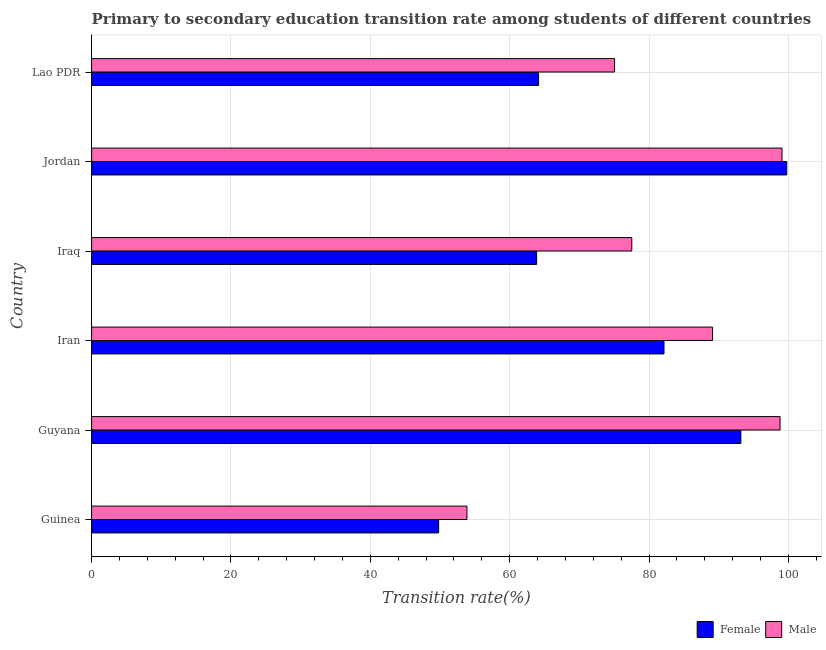How many different coloured bars are there?
Offer a terse response. 2. How many groups of bars are there?
Offer a very short reply. 6. Are the number of bars on each tick of the Y-axis equal?
Keep it short and to the point. Yes. How many bars are there on the 1st tick from the top?
Keep it short and to the point. 2. How many bars are there on the 5th tick from the bottom?
Offer a terse response. 2. What is the label of the 5th group of bars from the top?
Offer a very short reply. Guyana. What is the transition rate among female students in Guyana?
Keep it short and to the point. 93.18. Across all countries, what is the maximum transition rate among male students?
Make the answer very short. 99.08. Across all countries, what is the minimum transition rate among female students?
Provide a short and direct response. 49.81. In which country was the transition rate among female students maximum?
Your answer should be very brief. Jordan. In which country was the transition rate among male students minimum?
Offer a very short reply. Guinea. What is the total transition rate among female students in the graph?
Give a very brief answer. 452.93. What is the difference between the transition rate among male students in Guinea and that in Jordan?
Offer a very short reply. -45.22. What is the difference between the transition rate among male students in Guinea and the transition rate among female students in Lao PDR?
Ensure brevity in your answer.  -10.28. What is the average transition rate among male students per country?
Give a very brief answer. 82.25. What is the difference between the transition rate among male students and transition rate among female students in Lao PDR?
Offer a terse response. 10.91. What is the ratio of the transition rate among male students in Iran to that in Lao PDR?
Keep it short and to the point. 1.19. Is the difference between the transition rate among female students in Jordan and Lao PDR greater than the difference between the transition rate among male students in Jordan and Lao PDR?
Your answer should be compact. Yes. What is the difference between the highest and the second highest transition rate among female students?
Offer a terse response. 6.58. What is the difference between the highest and the lowest transition rate among male students?
Offer a very short reply. 45.22. Is the sum of the transition rate among male students in Guinea and Iran greater than the maximum transition rate among female students across all countries?
Offer a terse response. Yes. What does the 2nd bar from the top in Guyana represents?
Provide a short and direct response. Female. What does the 1st bar from the bottom in Iraq represents?
Give a very brief answer. Female. How many bars are there?
Your response must be concise. 12. Are all the bars in the graph horizontal?
Your answer should be compact. Yes. How many countries are there in the graph?
Offer a terse response. 6. What is the difference between two consecutive major ticks on the X-axis?
Give a very brief answer. 20. Are the values on the major ticks of X-axis written in scientific E-notation?
Offer a very short reply. No. Does the graph contain grids?
Your answer should be compact. Yes. Where does the legend appear in the graph?
Offer a terse response. Bottom right. How many legend labels are there?
Provide a short and direct response. 2. How are the legend labels stacked?
Keep it short and to the point. Horizontal. What is the title of the graph?
Offer a very short reply. Primary to secondary education transition rate among students of different countries. Does "Services" appear as one of the legend labels in the graph?
Offer a terse response. No. What is the label or title of the X-axis?
Keep it short and to the point. Transition rate(%). What is the Transition rate(%) of Female in Guinea?
Ensure brevity in your answer.  49.81. What is the Transition rate(%) of Male in Guinea?
Your response must be concise. 53.87. What is the Transition rate(%) in Female in Guyana?
Offer a very short reply. 93.18. What is the Transition rate(%) of Male in Guyana?
Keep it short and to the point. 98.81. What is the Transition rate(%) in Female in Iran?
Provide a short and direct response. 82.15. What is the Transition rate(%) of Male in Iran?
Your response must be concise. 89.12. What is the Transition rate(%) of Female in Iraq?
Ensure brevity in your answer.  63.87. What is the Transition rate(%) in Male in Iraq?
Offer a terse response. 77.53. What is the Transition rate(%) of Female in Jordan?
Make the answer very short. 99.77. What is the Transition rate(%) of Male in Jordan?
Offer a terse response. 99.08. What is the Transition rate(%) in Female in Lao PDR?
Ensure brevity in your answer.  64.15. What is the Transition rate(%) in Male in Lao PDR?
Provide a short and direct response. 75.06. Across all countries, what is the maximum Transition rate(%) in Female?
Your answer should be compact. 99.77. Across all countries, what is the maximum Transition rate(%) in Male?
Offer a very short reply. 99.08. Across all countries, what is the minimum Transition rate(%) in Female?
Provide a succinct answer. 49.81. Across all countries, what is the minimum Transition rate(%) in Male?
Provide a short and direct response. 53.87. What is the total Transition rate(%) in Female in the graph?
Offer a terse response. 452.93. What is the total Transition rate(%) in Male in the graph?
Offer a very short reply. 493.47. What is the difference between the Transition rate(%) of Female in Guinea and that in Guyana?
Your answer should be compact. -43.37. What is the difference between the Transition rate(%) of Male in Guinea and that in Guyana?
Offer a terse response. -44.94. What is the difference between the Transition rate(%) of Female in Guinea and that in Iran?
Offer a terse response. -32.34. What is the difference between the Transition rate(%) of Male in Guinea and that in Iran?
Give a very brief answer. -35.26. What is the difference between the Transition rate(%) in Female in Guinea and that in Iraq?
Your answer should be compact. -14.06. What is the difference between the Transition rate(%) in Male in Guinea and that in Iraq?
Your answer should be compact. -23.66. What is the difference between the Transition rate(%) of Female in Guinea and that in Jordan?
Provide a succinct answer. -49.96. What is the difference between the Transition rate(%) of Male in Guinea and that in Jordan?
Ensure brevity in your answer.  -45.22. What is the difference between the Transition rate(%) in Female in Guinea and that in Lao PDR?
Make the answer very short. -14.34. What is the difference between the Transition rate(%) in Male in Guinea and that in Lao PDR?
Offer a very short reply. -21.19. What is the difference between the Transition rate(%) in Female in Guyana and that in Iran?
Provide a short and direct response. 11.03. What is the difference between the Transition rate(%) in Male in Guyana and that in Iran?
Ensure brevity in your answer.  9.69. What is the difference between the Transition rate(%) in Female in Guyana and that in Iraq?
Your answer should be very brief. 29.31. What is the difference between the Transition rate(%) in Male in Guyana and that in Iraq?
Ensure brevity in your answer.  21.28. What is the difference between the Transition rate(%) of Female in Guyana and that in Jordan?
Your answer should be very brief. -6.58. What is the difference between the Transition rate(%) in Male in Guyana and that in Jordan?
Give a very brief answer. -0.28. What is the difference between the Transition rate(%) of Female in Guyana and that in Lao PDR?
Offer a terse response. 29.03. What is the difference between the Transition rate(%) of Male in Guyana and that in Lao PDR?
Your response must be concise. 23.75. What is the difference between the Transition rate(%) in Female in Iran and that in Iraq?
Provide a short and direct response. 18.28. What is the difference between the Transition rate(%) of Male in Iran and that in Iraq?
Offer a very short reply. 11.59. What is the difference between the Transition rate(%) in Female in Iran and that in Jordan?
Provide a succinct answer. -17.62. What is the difference between the Transition rate(%) in Male in Iran and that in Jordan?
Provide a short and direct response. -9.96. What is the difference between the Transition rate(%) in Female in Iran and that in Lao PDR?
Make the answer very short. 18. What is the difference between the Transition rate(%) in Male in Iran and that in Lao PDR?
Your answer should be very brief. 14.07. What is the difference between the Transition rate(%) of Female in Iraq and that in Jordan?
Offer a very short reply. -35.9. What is the difference between the Transition rate(%) in Male in Iraq and that in Jordan?
Ensure brevity in your answer.  -21.56. What is the difference between the Transition rate(%) in Female in Iraq and that in Lao PDR?
Give a very brief answer. -0.28. What is the difference between the Transition rate(%) in Male in Iraq and that in Lao PDR?
Offer a terse response. 2.47. What is the difference between the Transition rate(%) of Female in Jordan and that in Lao PDR?
Provide a succinct answer. 35.62. What is the difference between the Transition rate(%) in Male in Jordan and that in Lao PDR?
Provide a short and direct response. 24.03. What is the difference between the Transition rate(%) of Female in Guinea and the Transition rate(%) of Male in Guyana?
Your answer should be compact. -49. What is the difference between the Transition rate(%) in Female in Guinea and the Transition rate(%) in Male in Iran?
Keep it short and to the point. -39.31. What is the difference between the Transition rate(%) of Female in Guinea and the Transition rate(%) of Male in Iraq?
Provide a succinct answer. -27.72. What is the difference between the Transition rate(%) of Female in Guinea and the Transition rate(%) of Male in Jordan?
Make the answer very short. -49.28. What is the difference between the Transition rate(%) of Female in Guinea and the Transition rate(%) of Male in Lao PDR?
Offer a very short reply. -25.25. What is the difference between the Transition rate(%) in Female in Guyana and the Transition rate(%) in Male in Iran?
Your answer should be compact. 4.06. What is the difference between the Transition rate(%) of Female in Guyana and the Transition rate(%) of Male in Iraq?
Provide a succinct answer. 15.65. What is the difference between the Transition rate(%) of Female in Guyana and the Transition rate(%) of Male in Jordan?
Your answer should be compact. -5.9. What is the difference between the Transition rate(%) of Female in Guyana and the Transition rate(%) of Male in Lao PDR?
Ensure brevity in your answer.  18.13. What is the difference between the Transition rate(%) in Female in Iran and the Transition rate(%) in Male in Iraq?
Your answer should be compact. 4.62. What is the difference between the Transition rate(%) in Female in Iran and the Transition rate(%) in Male in Jordan?
Your answer should be compact. -16.93. What is the difference between the Transition rate(%) in Female in Iran and the Transition rate(%) in Male in Lao PDR?
Make the answer very short. 7.09. What is the difference between the Transition rate(%) in Female in Iraq and the Transition rate(%) in Male in Jordan?
Your answer should be compact. -35.21. What is the difference between the Transition rate(%) of Female in Iraq and the Transition rate(%) of Male in Lao PDR?
Provide a short and direct response. -11.18. What is the difference between the Transition rate(%) in Female in Jordan and the Transition rate(%) in Male in Lao PDR?
Provide a succinct answer. 24.71. What is the average Transition rate(%) of Female per country?
Give a very brief answer. 75.49. What is the average Transition rate(%) in Male per country?
Make the answer very short. 82.24. What is the difference between the Transition rate(%) of Female and Transition rate(%) of Male in Guinea?
Ensure brevity in your answer.  -4.06. What is the difference between the Transition rate(%) of Female and Transition rate(%) of Male in Guyana?
Your response must be concise. -5.63. What is the difference between the Transition rate(%) of Female and Transition rate(%) of Male in Iran?
Ensure brevity in your answer.  -6.97. What is the difference between the Transition rate(%) in Female and Transition rate(%) in Male in Iraq?
Your answer should be very brief. -13.66. What is the difference between the Transition rate(%) of Female and Transition rate(%) of Male in Jordan?
Give a very brief answer. 0.68. What is the difference between the Transition rate(%) in Female and Transition rate(%) in Male in Lao PDR?
Make the answer very short. -10.91. What is the ratio of the Transition rate(%) in Female in Guinea to that in Guyana?
Give a very brief answer. 0.53. What is the ratio of the Transition rate(%) in Male in Guinea to that in Guyana?
Your response must be concise. 0.55. What is the ratio of the Transition rate(%) in Female in Guinea to that in Iran?
Give a very brief answer. 0.61. What is the ratio of the Transition rate(%) of Male in Guinea to that in Iran?
Offer a very short reply. 0.6. What is the ratio of the Transition rate(%) of Female in Guinea to that in Iraq?
Your answer should be very brief. 0.78. What is the ratio of the Transition rate(%) of Male in Guinea to that in Iraq?
Make the answer very short. 0.69. What is the ratio of the Transition rate(%) of Female in Guinea to that in Jordan?
Provide a succinct answer. 0.5. What is the ratio of the Transition rate(%) in Male in Guinea to that in Jordan?
Offer a terse response. 0.54. What is the ratio of the Transition rate(%) in Female in Guinea to that in Lao PDR?
Your answer should be compact. 0.78. What is the ratio of the Transition rate(%) in Male in Guinea to that in Lao PDR?
Your response must be concise. 0.72. What is the ratio of the Transition rate(%) in Female in Guyana to that in Iran?
Ensure brevity in your answer.  1.13. What is the ratio of the Transition rate(%) of Male in Guyana to that in Iran?
Keep it short and to the point. 1.11. What is the ratio of the Transition rate(%) in Female in Guyana to that in Iraq?
Make the answer very short. 1.46. What is the ratio of the Transition rate(%) of Male in Guyana to that in Iraq?
Provide a succinct answer. 1.27. What is the ratio of the Transition rate(%) in Female in Guyana to that in Jordan?
Keep it short and to the point. 0.93. What is the ratio of the Transition rate(%) in Female in Guyana to that in Lao PDR?
Offer a terse response. 1.45. What is the ratio of the Transition rate(%) of Male in Guyana to that in Lao PDR?
Give a very brief answer. 1.32. What is the ratio of the Transition rate(%) of Female in Iran to that in Iraq?
Your response must be concise. 1.29. What is the ratio of the Transition rate(%) of Male in Iran to that in Iraq?
Give a very brief answer. 1.15. What is the ratio of the Transition rate(%) of Female in Iran to that in Jordan?
Your answer should be compact. 0.82. What is the ratio of the Transition rate(%) of Male in Iran to that in Jordan?
Your response must be concise. 0.9. What is the ratio of the Transition rate(%) in Female in Iran to that in Lao PDR?
Provide a short and direct response. 1.28. What is the ratio of the Transition rate(%) of Male in Iran to that in Lao PDR?
Offer a terse response. 1.19. What is the ratio of the Transition rate(%) in Female in Iraq to that in Jordan?
Offer a terse response. 0.64. What is the ratio of the Transition rate(%) in Male in Iraq to that in Jordan?
Your response must be concise. 0.78. What is the ratio of the Transition rate(%) in Female in Iraq to that in Lao PDR?
Your answer should be very brief. 1. What is the ratio of the Transition rate(%) of Male in Iraq to that in Lao PDR?
Make the answer very short. 1.03. What is the ratio of the Transition rate(%) of Female in Jordan to that in Lao PDR?
Give a very brief answer. 1.56. What is the ratio of the Transition rate(%) in Male in Jordan to that in Lao PDR?
Your answer should be very brief. 1.32. What is the difference between the highest and the second highest Transition rate(%) of Female?
Make the answer very short. 6.58. What is the difference between the highest and the second highest Transition rate(%) in Male?
Keep it short and to the point. 0.28. What is the difference between the highest and the lowest Transition rate(%) in Female?
Give a very brief answer. 49.96. What is the difference between the highest and the lowest Transition rate(%) in Male?
Your answer should be very brief. 45.22. 